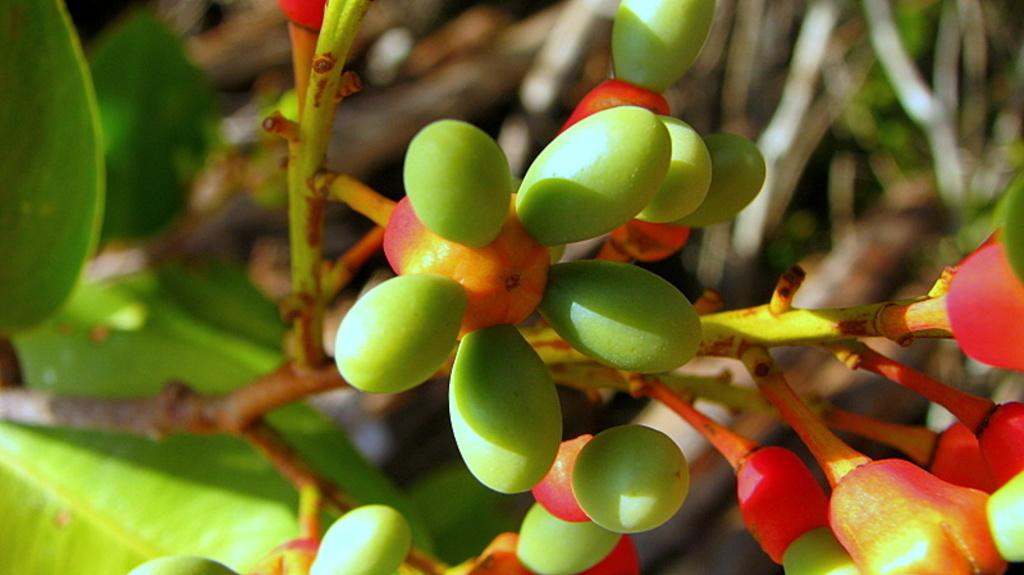What is attached to the stem of the plant in the image? There are fruits attached to the stem of a plant in the image. What else can be seen in the image besides the fruits? There are leaves in the image. Can you describe the background of the image? The backdrop of the image is blurred. How many chickens are present in the image? There are no chickens present in the image. What type of territory is depicted in the image? The image does not depict any territory; it features fruits and leaves on a plant. 